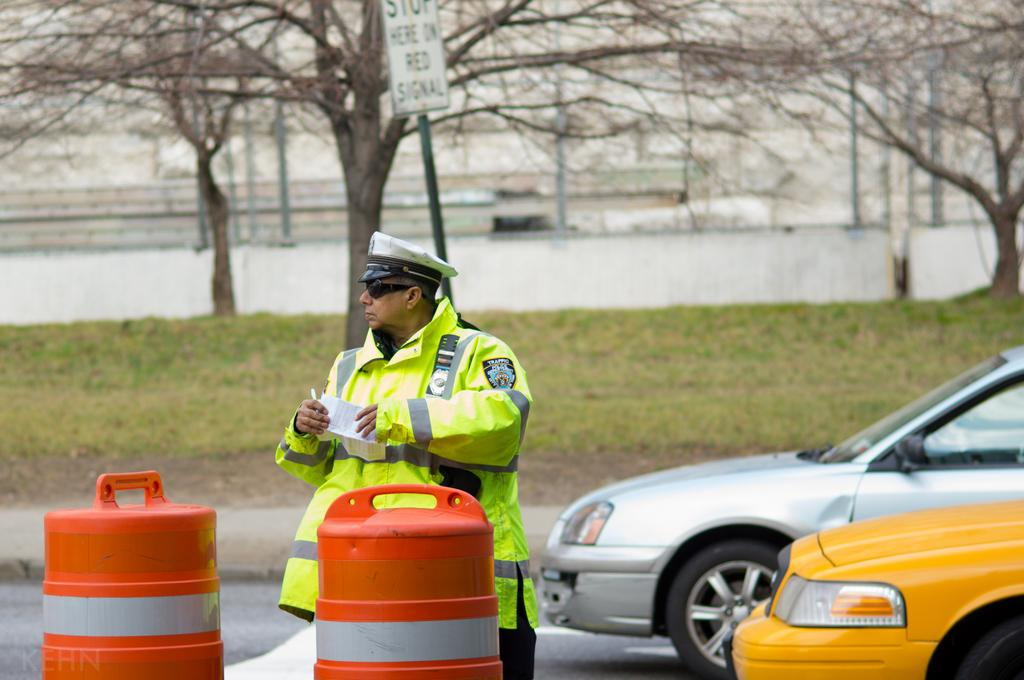Provide a one-sentence caption for the provided image. A man who works for the traffic police department looks to be writing a ticket. 